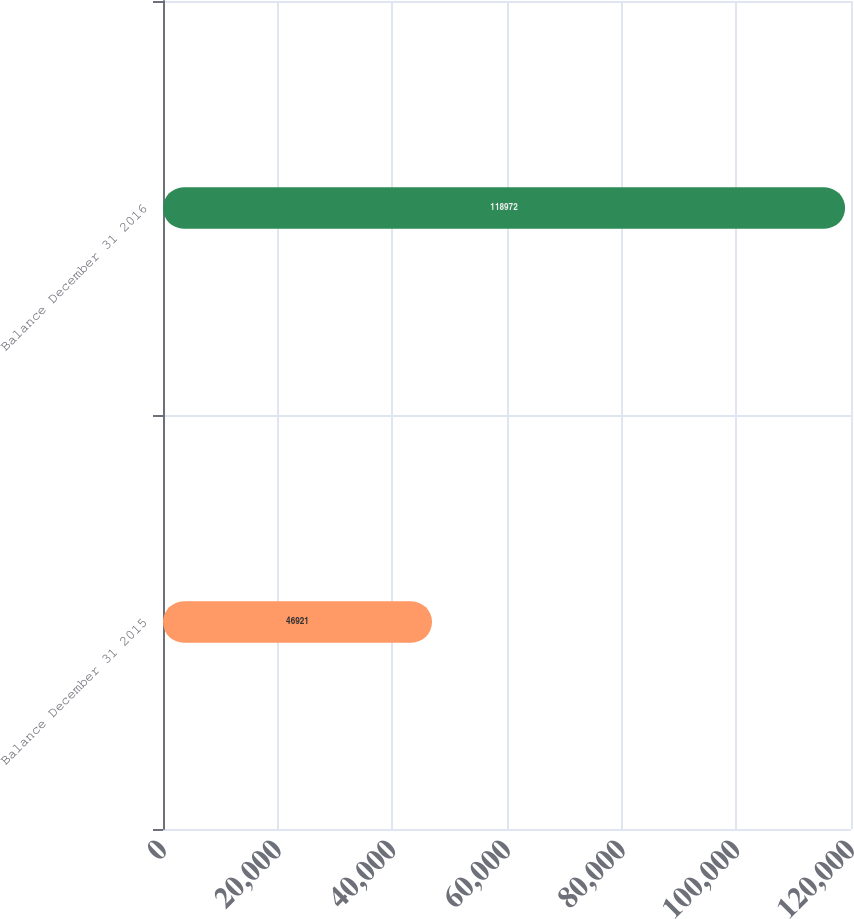<chart> <loc_0><loc_0><loc_500><loc_500><bar_chart><fcel>Balance December 31 2015<fcel>Balance December 31 2016<nl><fcel>46921<fcel>118972<nl></chart> 